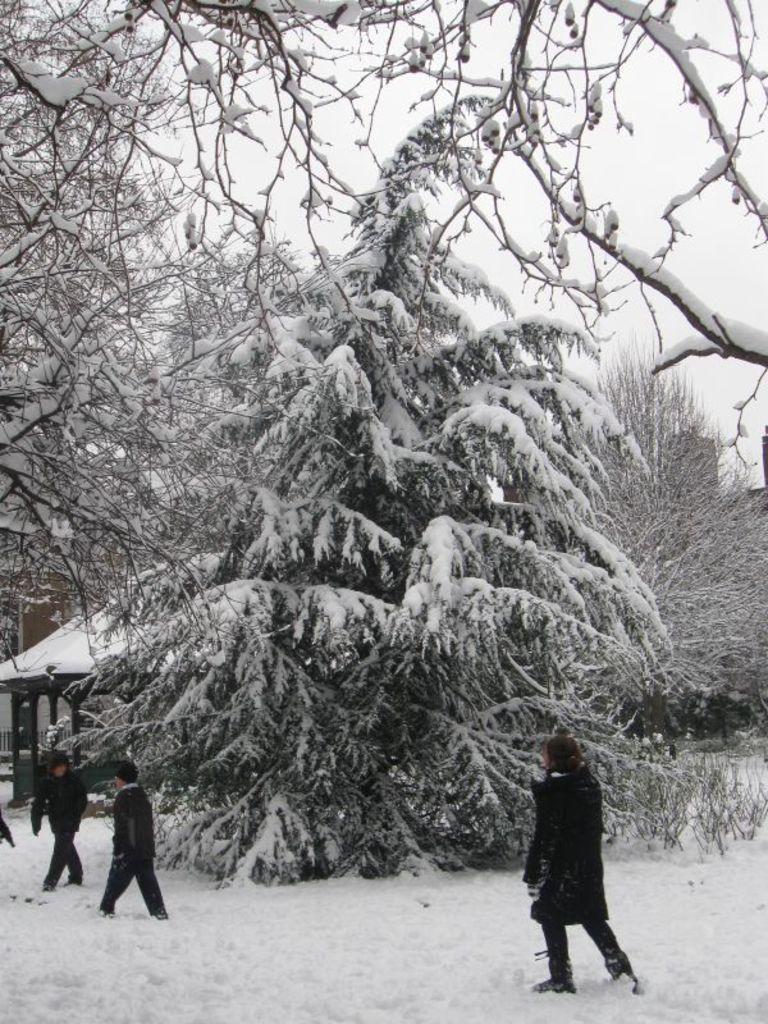Can you describe this image briefly? In this image we can see trees, there is snow on it, here are the persons standing, at above here is the sky. 